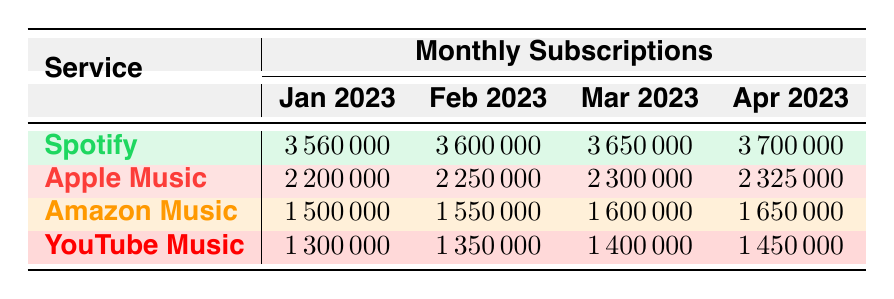What is the total number of subscriptions for Apple Music in April 2023? The table shows that Apple Music had 2,325,000 subscriptions in April 2023. This is a retrieval question that can be directly answered from the table without the need for any calculations.
Answer: 2,325,000 Which service had the highest number of subscriptions in March 2023? In March 2023, the table indicates that Spotify had 3,650,000 subscriptions, which is higher than any other service in that month. Therefore, the answer is derived simply by comparing the values in the March column for each service.
Answer: Spotify What is the difference in subscriptions between Spotify in January 2023 and April 2023? The number of subscriptions for Spotify in January 2023 is 3,560,000 and in April 2023 is 3,700,000. To find the difference, subtract the two values: 3,700,000 - 3,560,000 = 140,000. The answer shows how much Spotify grew in terms of subscriptions over this period.
Answer: 140,000 Is it true that YouTube Music had more subscriptions than Amazon Music in February 2023? In February 2023, YouTube Music had 1,350,000 subscriptions while Amazon Music had 1,550,000 subscriptions. Since 1,350,000 is less than 1,550,000, the statement is false. This is a fact-based question that can be answered by comparing the values directly.
Answer: No What was the average number of subscriptions for Amazon Music over the four months? The total subscriptions for Amazon Music over the four months are: January (1,500,000), February (1,550,000), March (1,600,000), and April (1,650,000). Summing these gives: 1,500,000 + 1,550,000 + 1,600,000 + 1,650,000 = 6,300,000. To find the average, divide by 4 (the number of months): 6,300,000 / 4 = 1,575,000. This involves basic addition to get the total, then division to get the average.
Answer: 1,575,000 In which month did Apple Music experience the smallest increase in subscriptions compared to the previous month? Analyzing the table, the increases for Apple Music are: February (25,000 from January), March (50,000 from February), and April (25,000 from March). The smallest increase is thus 25,000, occurring between both January to February and March to April. Identifying the months of these increases provides the answer to the question.
Answer: January to February and March to April 